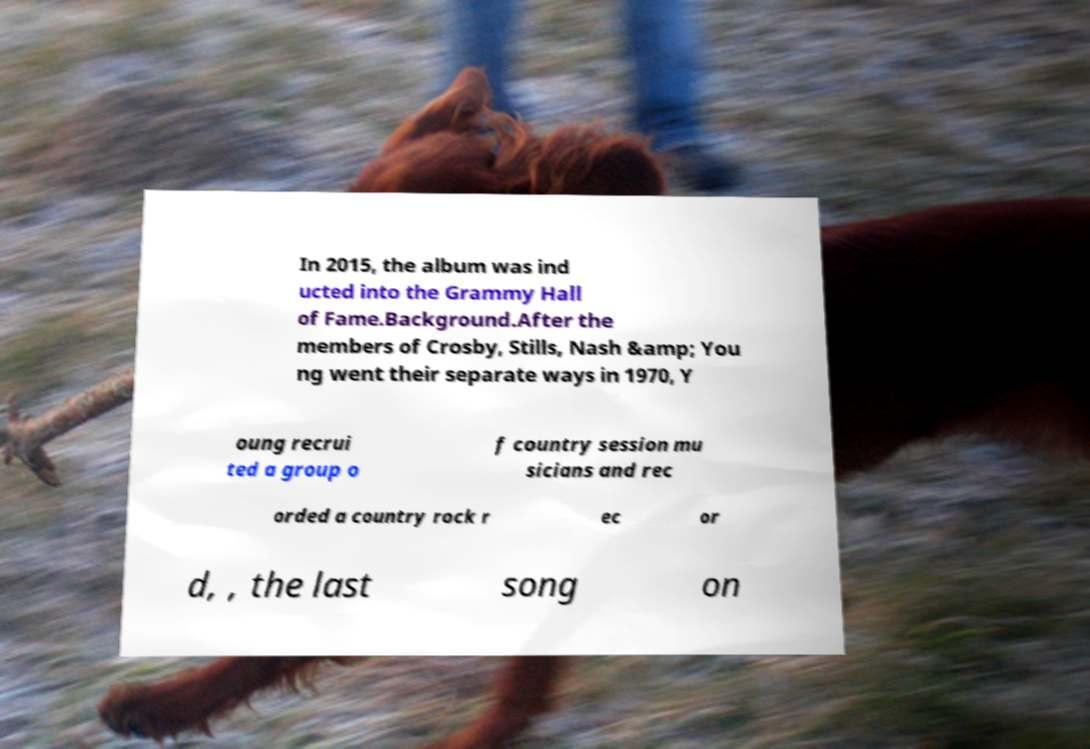Can you read and provide the text displayed in the image?This photo seems to have some interesting text. Can you extract and type it out for me? In 2015, the album was ind ucted into the Grammy Hall of Fame.Background.After the members of Crosby, Stills, Nash &amp; You ng went their separate ways in 1970, Y oung recrui ted a group o f country session mu sicians and rec orded a country rock r ec or d, , the last song on 